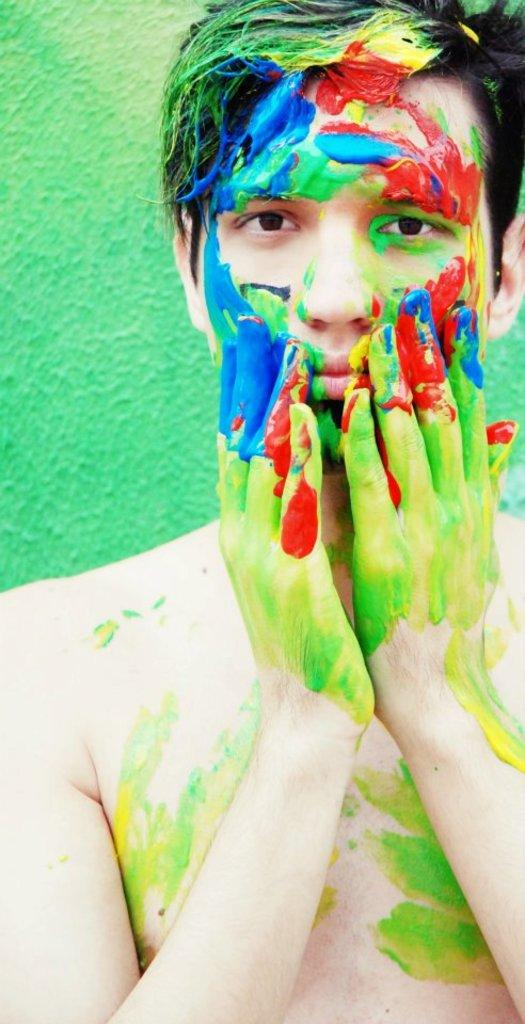What is the main subject in the foreground of the picture? There is a man in the foreground of the picture. What can be observed on the man's face and hands? The man has paint on his face and hands. How does the man appear to be feeling in the picture? The man appears to be in pain or distress. What color is the wall visible in the background of the picture? There is a green wall in the background of the picture. What type of cheese is being prepared on the stove in the image? There is no stove or cheese present in the image; it features a man with paint on his face and hands in front of a green wall. 